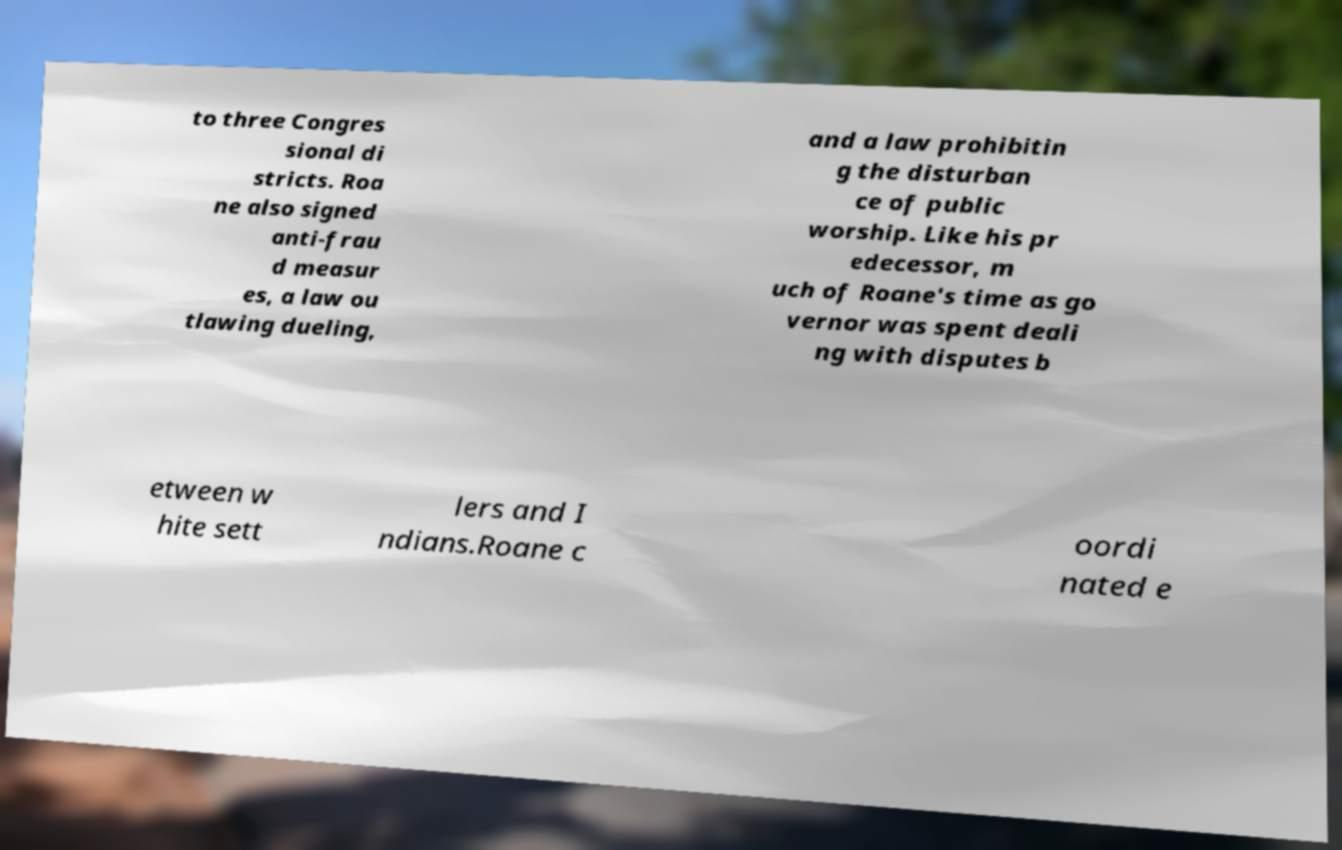What messages or text are displayed in this image? I need them in a readable, typed format. to three Congres sional di stricts. Roa ne also signed anti-frau d measur es, a law ou tlawing dueling, and a law prohibitin g the disturban ce of public worship. Like his pr edecessor, m uch of Roane's time as go vernor was spent deali ng with disputes b etween w hite sett lers and I ndians.Roane c oordi nated e 